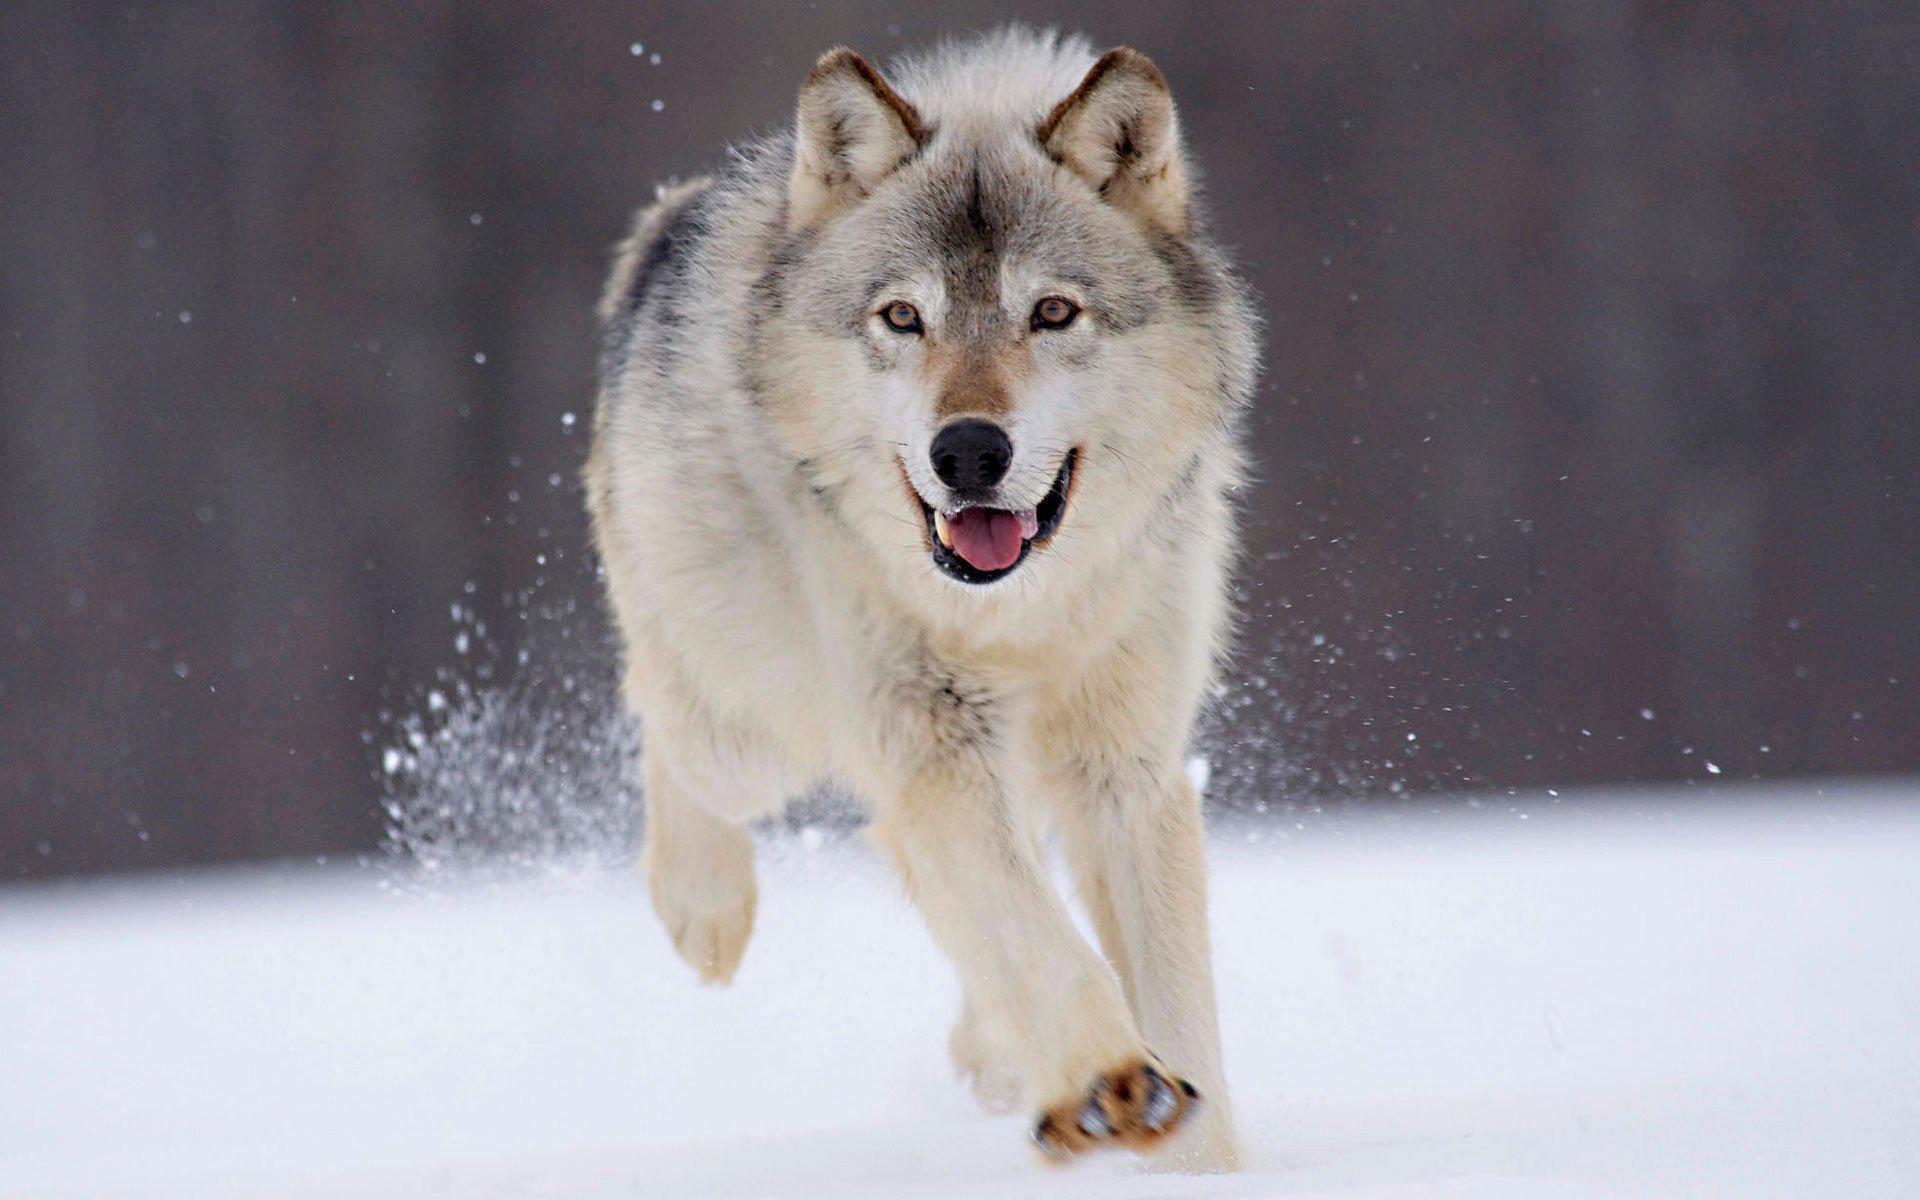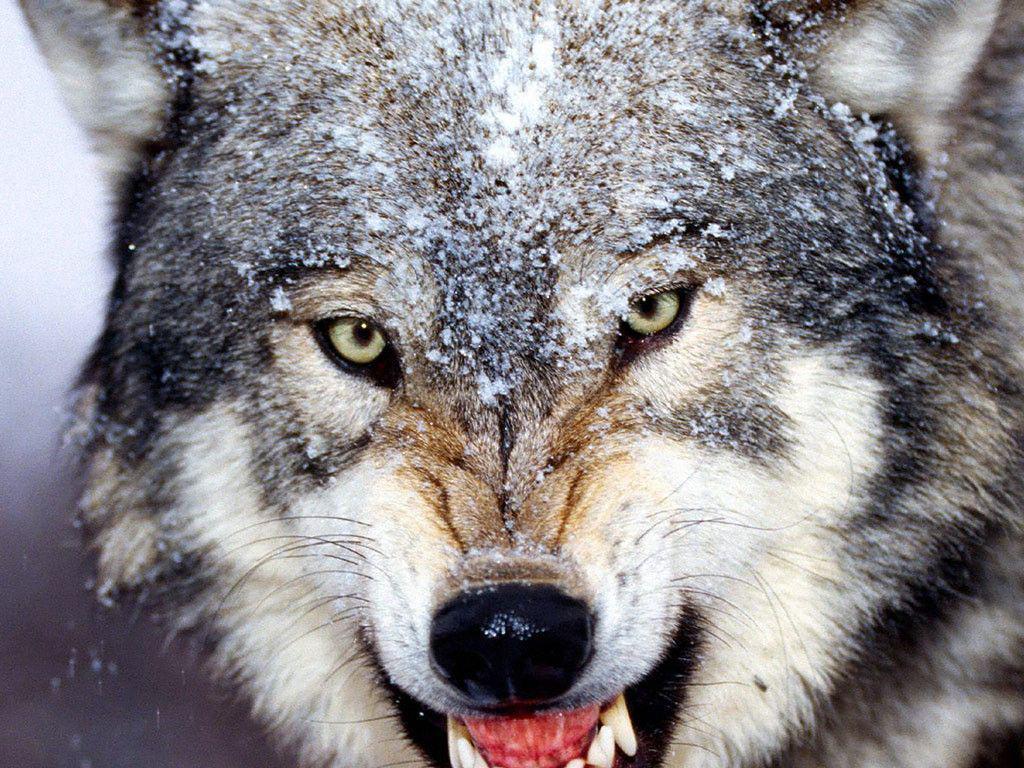The first image is the image on the left, the second image is the image on the right. Analyze the images presented: Is the assertion "There are 2 wolves facing forward." valid? Answer yes or no. Yes. 